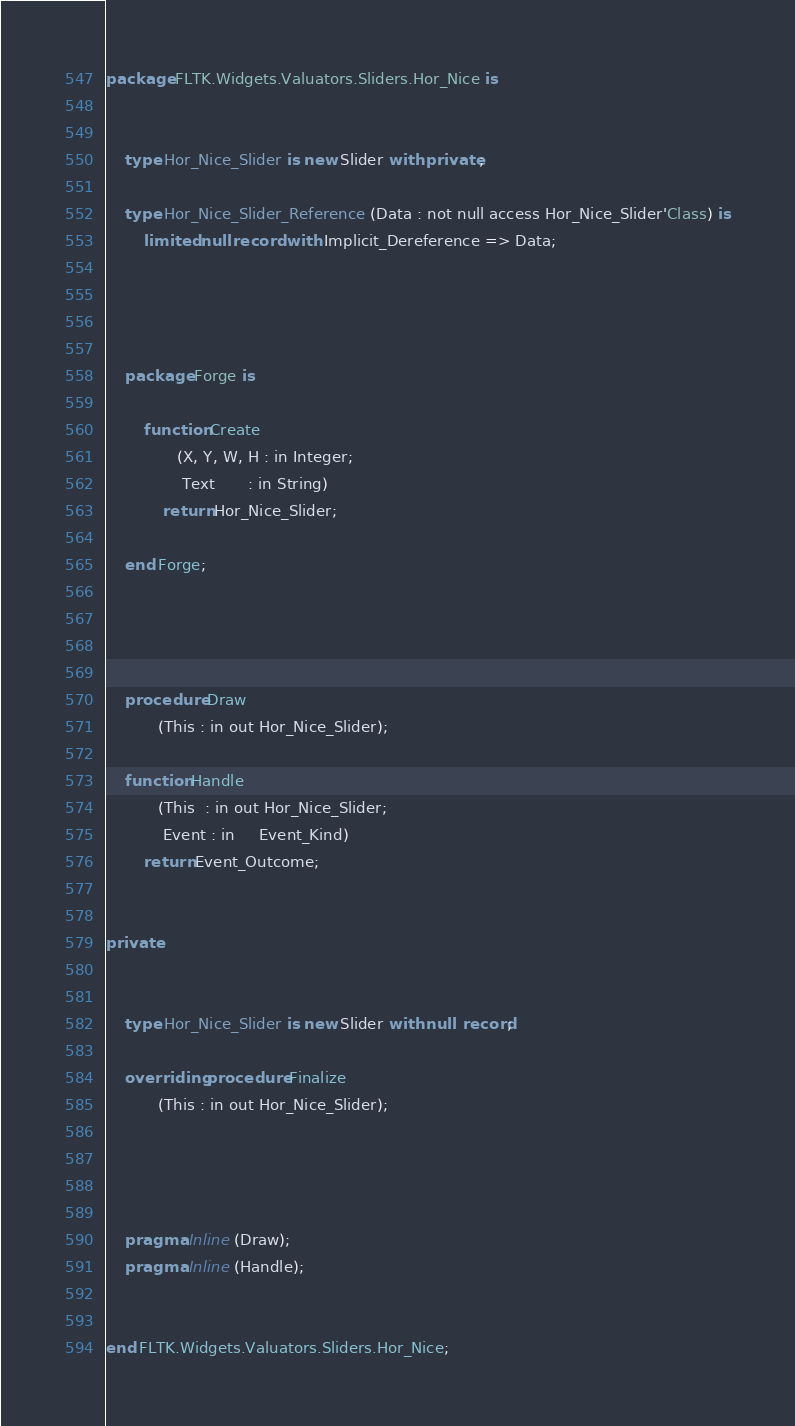<code> <loc_0><loc_0><loc_500><loc_500><_Ada_>

package FLTK.Widgets.Valuators.Sliders.Hor_Nice is


    type Hor_Nice_Slider is new Slider with private;

    type Hor_Nice_Slider_Reference (Data : not null access Hor_Nice_Slider'Class) is
        limited null record with Implicit_Dereference => Data;




    package Forge is

        function Create
               (X, Y, W, H : in Integer;
                Text       : in String)
            return Hor_Nice_Slider;

    end Forge;




    procedure Draw
           (This : in out Hor_Nice_Slider);

    function Handle
           (This  : in out Hor_Nice_Slider;
            Event : in     Event_Kind)
        return Event_Outcome;


private


    type Hor_Nice_Slider is new Slider with null record;

    overriding procedure Finalize
           (This : in out Hor_Nice_Slider);




    pragma Inline (Draw);
    pragma Inline (Handle);


end FLTK.Widgets.Valuators.Sliders.Hor_Nice;

</code> 